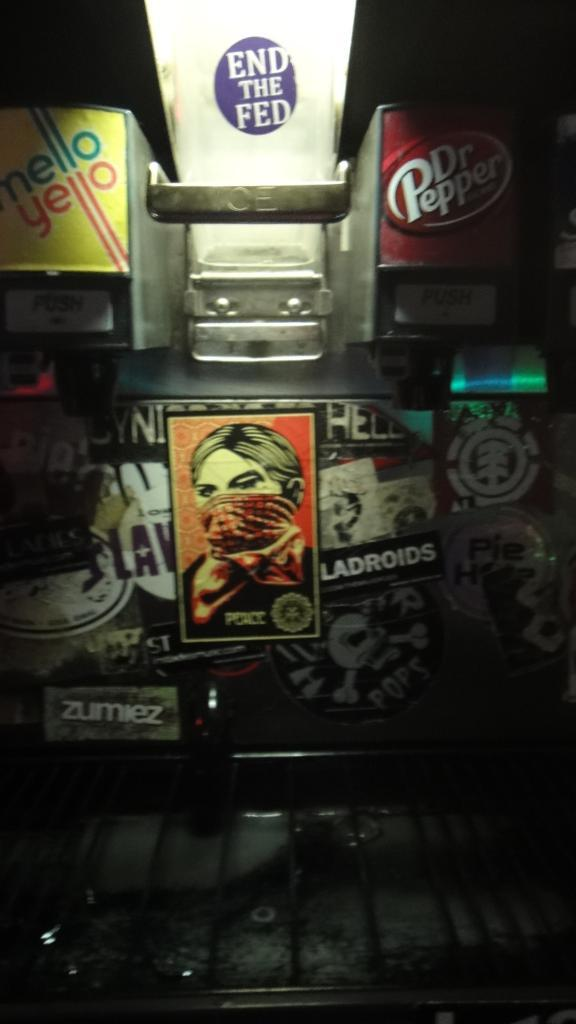<image>
Write a terse but informative summary of the picture. The purple sticker in the middle that reads End The Fed. 